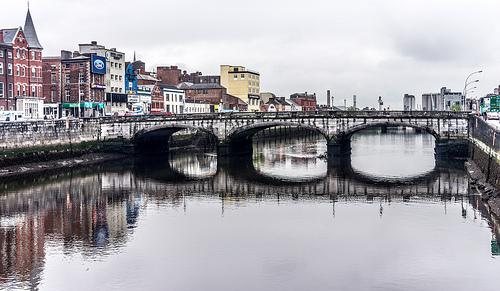Question: where is this photo taken?
Choices:
A. A canal.
B. A street.
C. At the zoo.
D. My house.
Answer with the letter. Answer: A Question: where is the bridge?
Choices:
A. Over the highway.
B. Over the canal.
C. In the woods.
D. Over the stream.
Answer with the letter. Answer: B Question: what does the sky look like?
Choices:
A. Blue.
B. Overcast.
C. Sunny.
D. Clear.
Answer with the letter. Answer: B Question: what is in the background?
Choices:
A. A monkey.
B. A city.
C. A crowd.
D. A street.
Answer with the letter. Answer: B Question: when was the photo taken?
Choices:
A. Yesterday.
B. At night.
C. Twilight.
D. Daytime.
Answer with the letter. Answer: D Question: how many arches does the bridge have?
Choices:
A. Three.
B. One.
C. Two.
D. Four.
Answer with the letter. Answer: A 